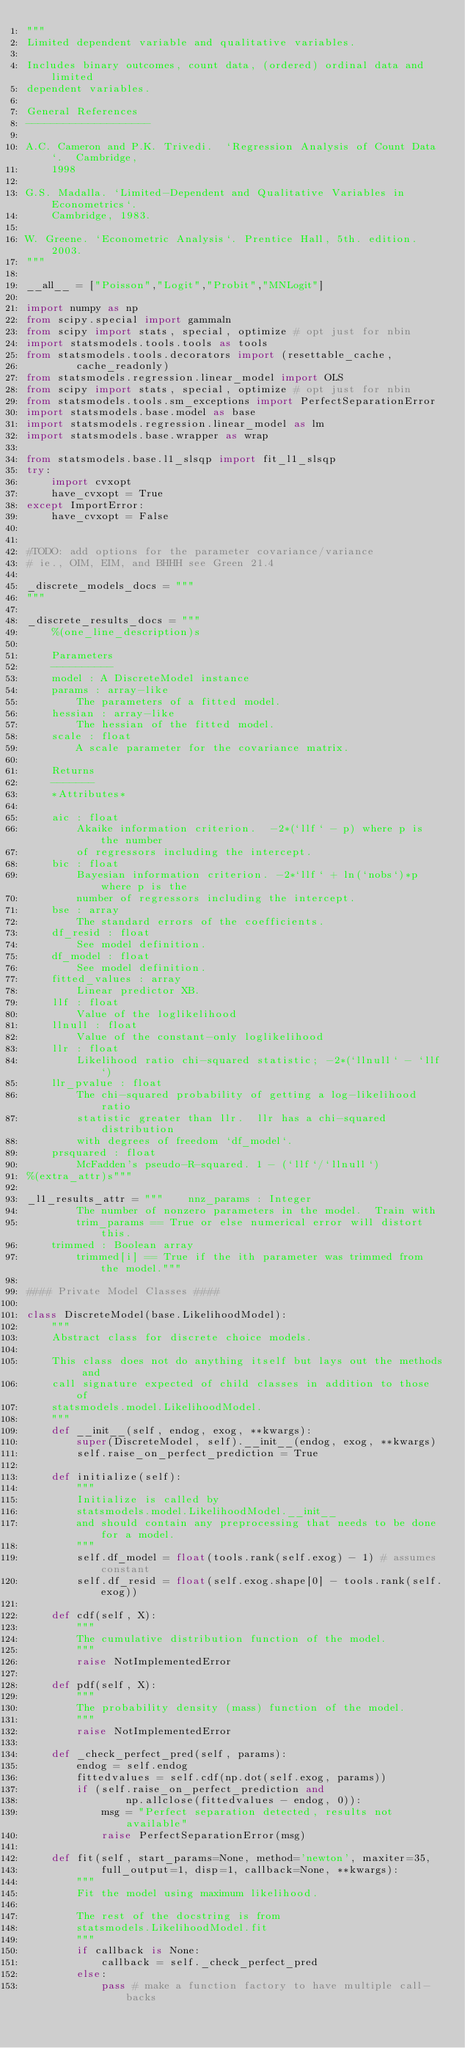<code> <loc_0><loc_0><loc_500><loc_500><_Python_>"""
Limited dependent variable and qualitative variables.

Includes binary outcomes, count data, (ordered) ordinal data and limited
dependent variables.

General References
--------------------

A.C. Cameron and P.K. Trivedi.  `Regression Analysis of Count Data`.  Cambridge,
    1998

G.S. Madalla. `Limited-Dependent and Qualitative Variables in Econometrics`.
    Cambridge, 1983.

W. Greene. `Econometric Analysis`. Prentice Hall, 5th. edition. 2003.
"""

__all__ = ["Poisson","Logit","Probit","MNLogit"]

import numpy as np
from scipy.special import gammaln
from scipy import stats, special, optimize # opt just for nbin
import statsmodels.tools.tools as tools
from statsmodels.tools.decorators import (resettable_cache,
        cache_readonly)
from statsmodels.regression.linear_model import OLS
from scipy import stats, special, optimize # opt just for nbin
from statsmodels.tools.sm_exceptions import PerfectSeparationError
import statsmodels.base.model as base
import statsmodels.regression.linear_model as lm
import statsmodels.base.wrapper as wrap

from statsmodels.base.l1_slsqp import fit_l1_slsqp
try:
    import cvxopt
    have_cvxopt = True
except ImportError:
    have_cvxopt = False


#TODO: add options for the parameter covariance/variance
# ie., OIM, EIM, and BHHH see Green 21.4

_discrete_models_docs = """
"""

_discrete_results_docs = """
    %(one_line_description)s

    Parameters
    ----------
    model : A DiscreteModel instance
    params : array-like
        The parameters of a fitted model.
    hessian : array-like
        The hessian of the fitted model.
    scale : float
        A scale parameter for the covariance matrix.

    Returns
    -------
    *Attributes*

    aic : float
        Akaike information criterion.  -2*(`llf` - p) where p is the number
        of regressors including the intercept.
    bic : float
        Bayesian information criterion. -2*`llf` + ln(`nobs`)*p where p is the
        number of regressors including the intercept.
    bse : array
        The standard errors of the coefficients.
    df_resid : float
        See model definition.
    df_model : float
        See model definition.
    fitted_values : array
        Linear predictor XB.
    llf : float
        Value of the loglikelihood
    llnull : float
        Value of the constant-only loglikelihood
    llr : float
        Likelihood ratio chi-squared statistic; -2*(`llnull` - `llf`)
    llr_pvalue : float
        The chi-squared probability of getting a log-likelihood ratio
        statistic greater than llr.  llr has a chi-squared distribution
        with degrees of freedom `df_model`.
    prsquared : float
        McFadden's pseudo-R-squared. 1 - (`llf`/`llnull`)
%(extra_attr)s"""

_l1_results_attr = """    nnz_params : Integer
        The number of nonzero parameters in the model.  Train with
        trim_params == True or else numerical error will distort this.
    trimmed : Boolean array
        trimmed[i] == True if the ith parameter was trimmed from the model."""

#### Private Model Classes ####

class DiscreteModel(base.LikelihoodModel):
    """
    Abstract class for discrete choice models.

    This class does not do anything itself but lays out the methods and
    call signature expected of child classes in addition to those of
    statsmodels.model.LikelihoodModel.
    """
    def __init__(self, endog, exog, **kwargs):
        super(DiscreteModel, self).__init__(endog, exog, **kwargs)
        self.raise_on_perfect_prediction = True

    def initialize(self):
        """
        Initialize is called by
        statsmodels.model.LikelihoodModel.__init__
        and should contain any preprocessing that needs to be done for a model.
        """
        self.df_model = float(tools.rank(self.exog) - 1) # assumes constant
        self.df_resid = float(self.exog.shape[0] - tools.rank(self.exog))

    def cdf(self, X):
        """
        The cumulative distribution function of the model.
        """
        raise NotImplementedError

    def pdf(self, X):
        """
        The probability density (mass) function of the model.
        """
        raise NotImplementedError

    def _check_perfect_pred(self, params):
        endog = self.endog
        fittedvalues = self.cdf(np.dot(self.exog, params))
        if (self.raise_on_perfect_prediction and
                np.allclose(fittedvalues - endog, 0)):
            msg = "Perfect separation detected, results not available"
            raise PerfectSeparationError(msg)

    def fit(self, start_params=None, method='newton', maxiter=35,
            full_output=1, disp=1, callback=None, **kwargs):
        """
        Fit the model using maximum likelihood.

        The rest of the docstring is from
        statsmodels.LikelihoodModel.fit
        """
        if callback is None:
            callback = self._check_perfect_pred
        else:
            pass # make a function factory to have multiple call-backs</code> 